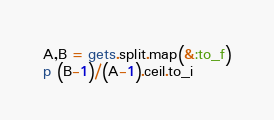Convert code to text. <code><loc_0><loc_0><loc_500><loc_500><_Ruby_>A,B = gets.split.map(&:to_f)
p (B-1)/(A-1).ceil.to_i</code> 